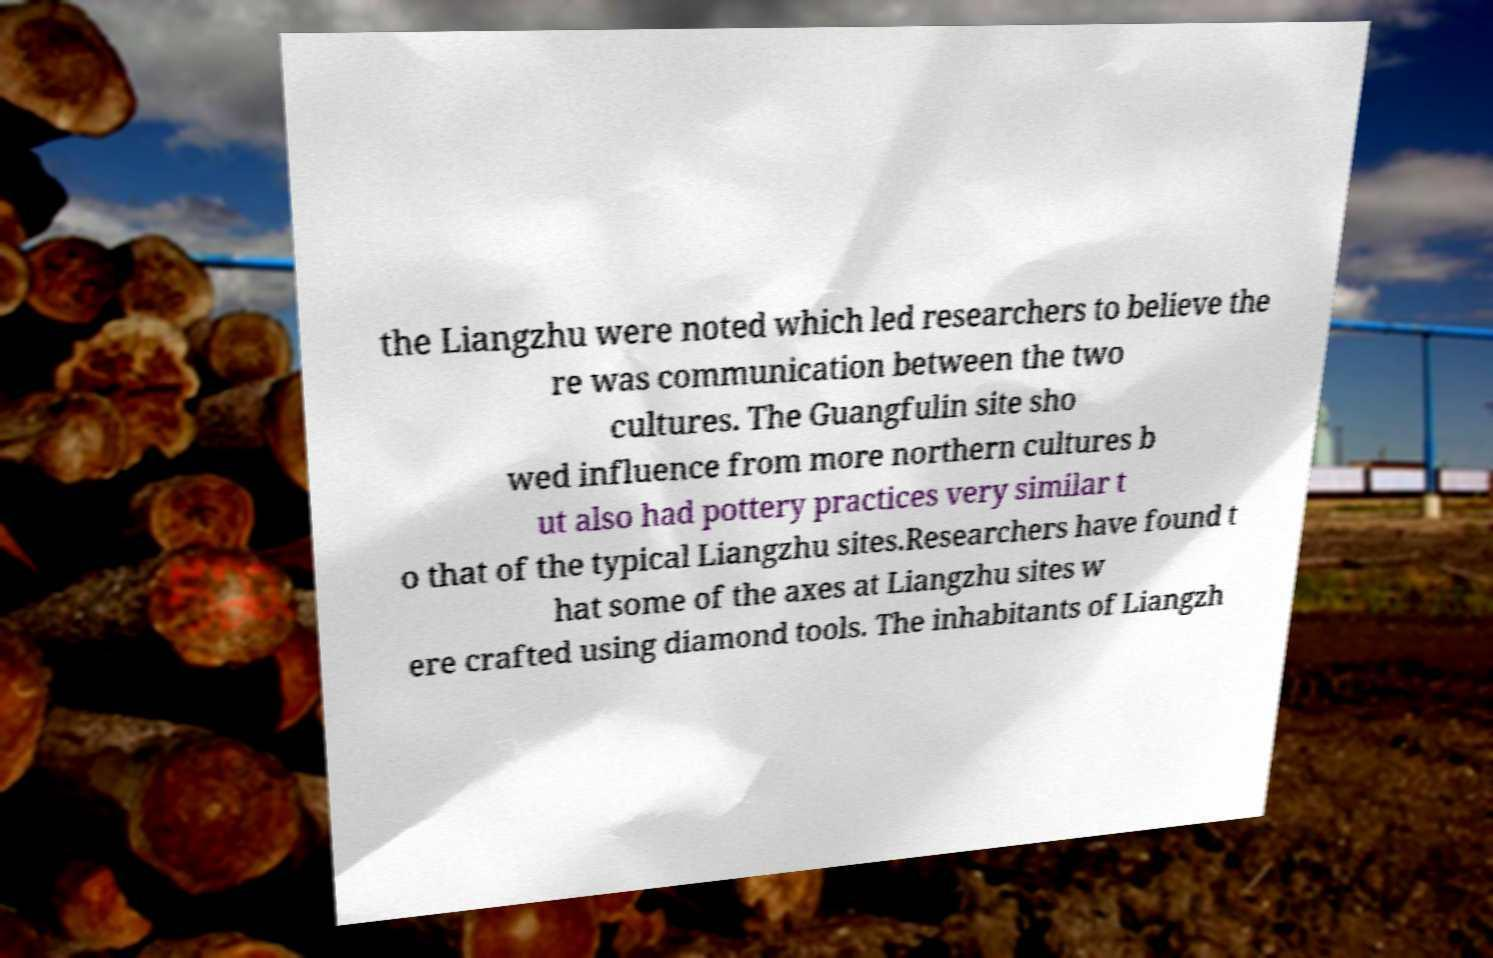For documentation purposes, I need the text within this image transcribed. Could you provide that? the Liangzhu were noted which led researchers to believe the re was communication between the two cultures. The Guangfulin site sho wed influence from more northern cultures b ut also had pottery practices very similar t o that of the typical Liangzhu sites.Researchers have found t hat some of the axes at Liangzhu sites w ere crafted using diamond tools. The inhabitants of Liangzh 